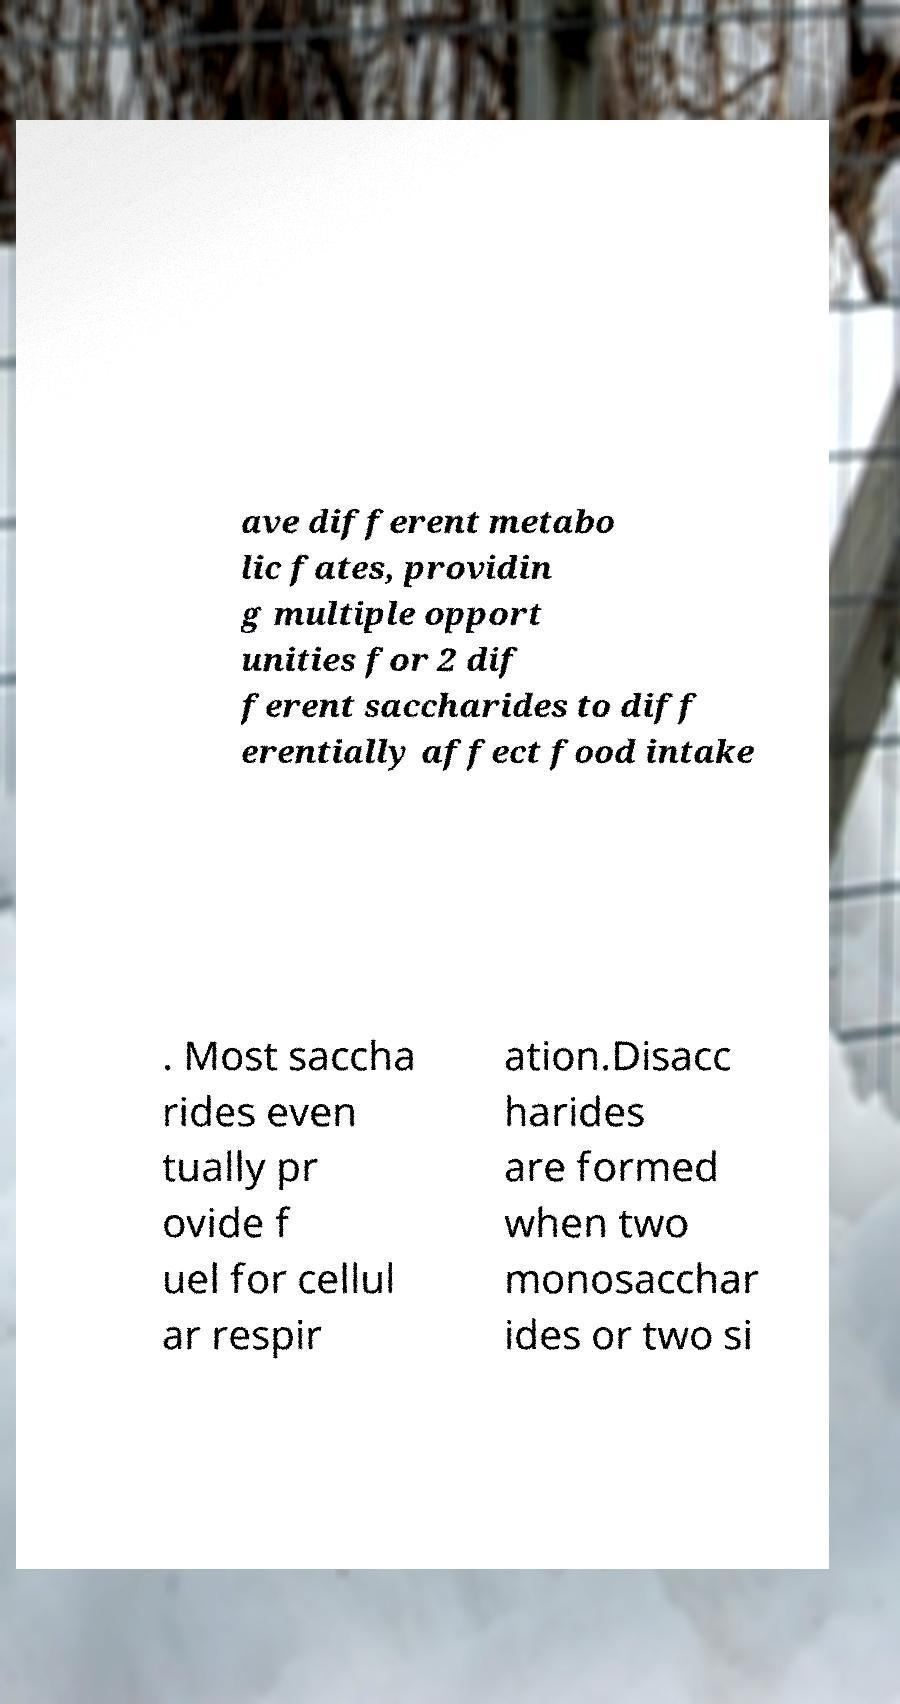Can you accurately transcribe the text from the provided image for me? ave different metabo lic fates, providin g multiple opport unities for 2 dif ferent saccharides to diff erentially affect food intake . Most saccha rides even tually pr ovide f uel for cellul ar respir ation.Disacc harides are formed when two monosacchar ides or two si 